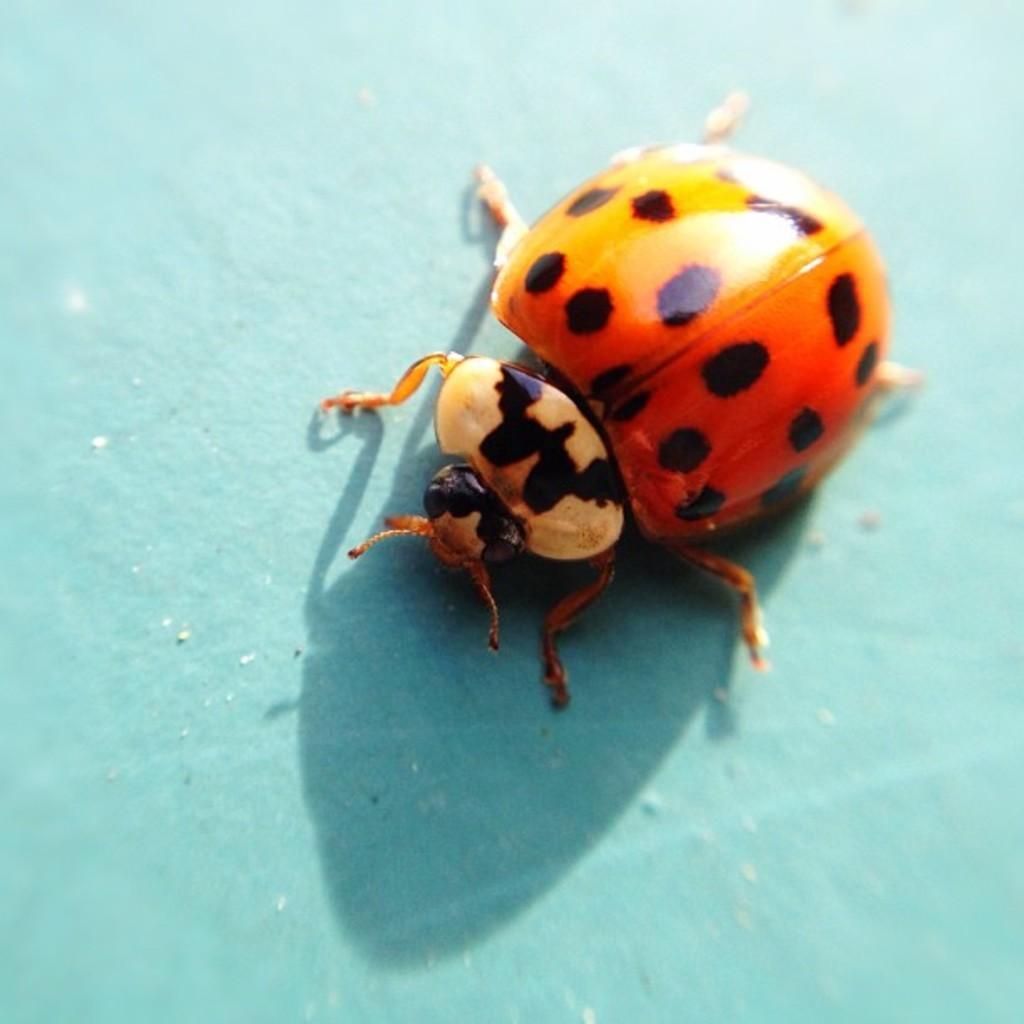Describe this image in one or two sentences. In this image I can see an insect in black and orange color and the insect is on the blue color surface. 